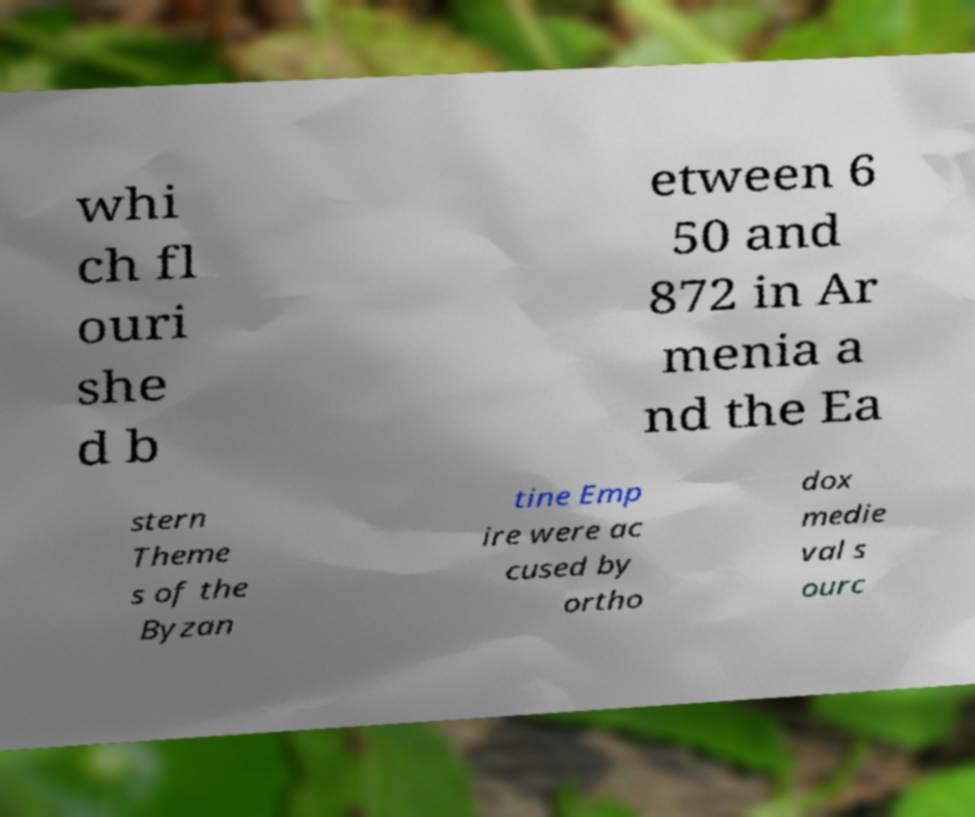Could you assist in decoding the text presented in this image and type it out clearly? whi ch fl ouri she d b etween 6 50 and 872 in Ar menia a nd the Ea stern Theme s of the Byzan tine Emp ire were ac cused by ortho dox medie val s ourc 